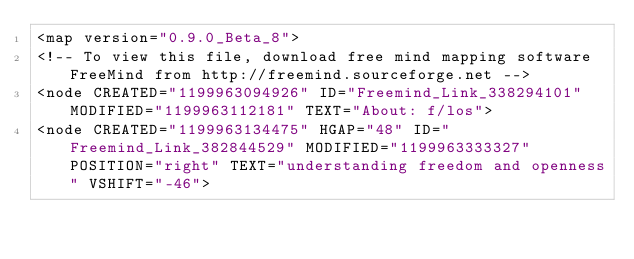Convert code to text. <code><loc_0><loc_0><loc_500><loc_500><_ObjectiveC_><map version="0.9.0_Beta_8">
<!-- To view this file, download free mind mapping software FreeMind from http://freemind.sourceforge.net -->
<node CREATED="1199963094926" ID="Freemind_Link_338294101" MODIFIED="1199963112181" TEXT="About: f/los">
<node CREATED="1199963134475" HGAP="48" ID="Freemind_Link_382844529" MODIFIED="1199963333327" POSITION="right" TEXT="understanding freedom and openness" VSHIFT="-46"></code> 